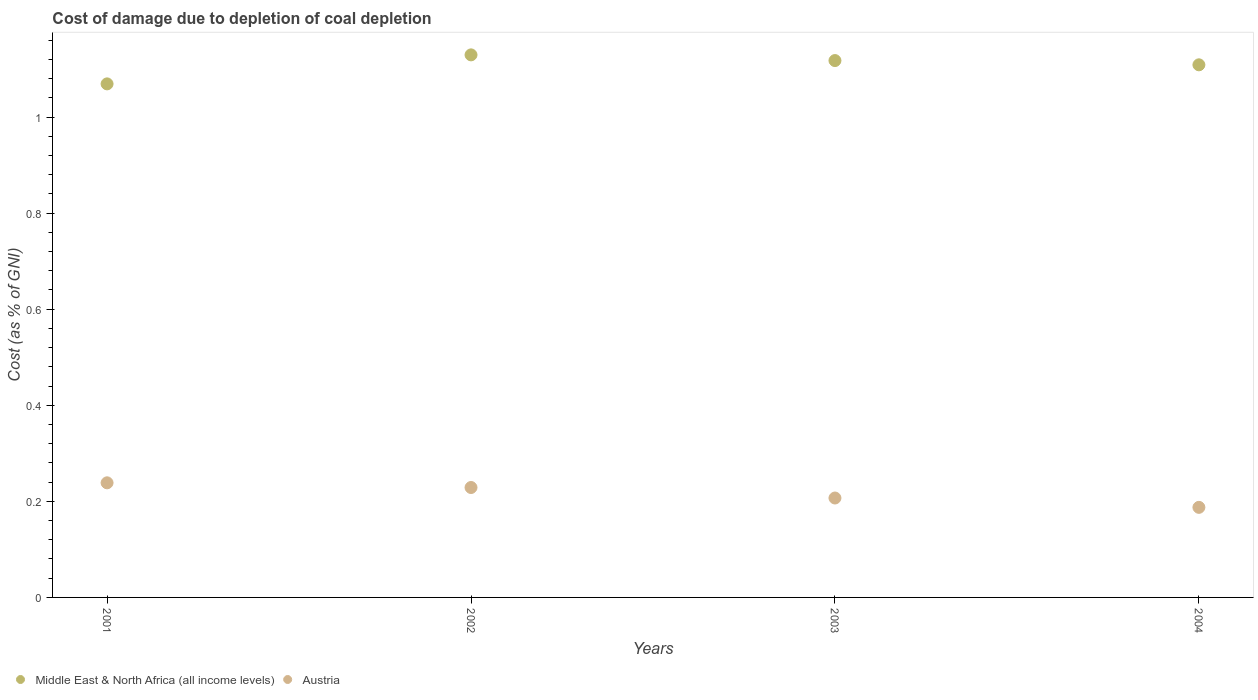What is the cost of damage caused due to coal depletion in Austria in 2003?
Provide a short and direct response. 0.21. Across all years, what is the maximum cost of damage caused due to coal depletion in Austria?
Give a very brief answer. 0.24. Across all years, what is the minimum cost of damage caused due to coal depletion in Austria?
Your answer should be very brief. 0.19. What is the total cost of damage caused due to coal depletion in Middle East & North Africa (all income levels) in the graph?
Make the answer very short. 4.42. What is the difference between the cost of damage caused due to coal depletion in Middle East & North Africa (all income levels) in 2001 and that in 2002?
Provide a succinct answer. -0.06. What is the difference between the cost of damage caused due to coal depletion in Middle East & North Africa (all income levels) in 2002 and the cost of damage caused due to coal depletion in Austria in 2003?
Keep it short and to the point. 0.92. What is the average cost of damage caused due to coal depletion in Austria per year?
Provide a short and direct response. 0.22. In the year 2002, what is the difference between the cost of damage caused due to coal depletion in Austria and cost of damage caused due to coal depletion in Middle East & North Africa (all income levels)?
Provide a short and direct response. -0.9. In how many years, is the cost of damage caused due to coal depletion in Austria greater than 0.68 %?
Offer a terse response. 0. What is the ratio of the cost of damage caused due to coal depletion in Austria in 2001 to that in 2004?
Your response must be concise. 1.27. Is the cost of damage caused due to coal depletion in Austria in 2002 less than that in 2004?
Ensure brevity in your answer.  No. Is the difference between the cost of damage caused due to coal depletion in Austria in 2002 and 2003 greater than the difference between the cost of damage caused due to coal depletion in Middle East & North Africa (all income levels) in 2002 and 2003?
Provide a short and direct response. Yes. What is the difference between the highest and the second highest cost of damage caused due to coal depletion in Austria?
Offer a terse response. 0.01. What is the difference between the highest and the lowest cost of damage caused due to coal depletion in Austria?
Keep it short and to the point. 0.05. Does the cost of damage caused due to coal depletion in Middle East & North Africa (all income levels) monotonically increase over the years?
Make the answer very short. No. How many dotlines are there?
Keep it short and to the point. 2. Does the graph contain any zero values?
Ensure brevity in your answer.  No. How many legend labels are there?
Offer a very short reply. 2. How are the legend labels stacked?
Ensure brevity in your answer.  Horizontal. What is the title of the graph?
Give a very brief answer. Cost of damage due to depletion of coal depletion. What is the label or title of the Y-axis?
Your answer should be very brief. Cost (as % of GNI). What is the Cost (as % of GNI) in Middle East & North Africa (all income levels) in 2001?
Keep it short and to the point. 1.07. What is the Cost (as % of GNI) in Austria in 2001?
Your answer should be compact. 0.24. What is the Cost (as % of GNI) of Middle East & North Africa (all income levels) in 2002?
Give a very brief answer. 1.13. What is the Cost (as % of GNI) of Austria in 2002?
Your answer should be compact. 0.23. What is the Cost (as % of GNI) of Middle East & North Africa (all income levels) in 2003?
Your answer should be very brief. 1.12. What is the Cost (as % of GNI) of Austria in 2003?
Your answer should be very brief. 0.21. What is the Cost (as % of GNI) of Middle East & North Africa (all income levels) in 2004?
Offer a very short reply. 1.11. What is the Cost (as % of GNI) in Austria in 2004?
Your answer should be compact. 0.19. Across all years, what is the maximum Cost (as % of GNI) of Middle East & North Africa (all income levels)?
Your response must be concise. 1.13. Across all years, what is the maximum Cost (as % of GNI) in Austria?
Give a very brief answer. 0.24. Across all years, what is the minimum Cost (as % of GNI) of Middle East & North Africa (all income levels)?
Your answer should be compact. 1.07. Across all years, what is the minimum Cost (as % of GNI) in Austria?
Provide a succinct answer. 0.19. What is the total Cost (as % of GNI) in Middle East & North Africa (all income levels) in the graph?
Your answer should be very brief. 4.42. What is the total Cost (as % of GNI) of Austria in the graph?
Offer a terse response. 0.86. What is the difference between the Cost (as % of GNI) of Middle East & North Africa (all income levels) in 2001 and that in 2002?
Keep it short and to the point. -0.06. What is the difference between the Cost (as % of GNI) in Austria in 2001 and that in 2002?
Provide a succinct answer. 0.01. What is the difference between the Cost (as % of GNI) of Middle East & North Africa (all income levels) in 2001 and that in 2003?
Keep it short and to the point. -0.05. What is the difference between the Cost (as % of GNI) of Austria in 2001 and that in 2003?
Make the answer very short. 0.03. What is the difference between the Cost (as % of GNI) in Middle East & North Africa (all income levels) in 2001 and that in 2004?
Keep it short and to the point. -0.04. What is the difference between the Cost (as % of GNI) of Austria in 2001 and that in 2004?
Ensure brevity in your answer.  0.05. What is the difference between the Cost (as % of GNI) in Middle East & North Africa (all income levels) in 2002 and that in 2003?
Your response must be concise. 0.01. What is the difference between the Cost (as % of GNI) of Austria in 2002 and that in 2003?
Provide a succinct answer. 0.02. What is the difference between the Cost (as % of GNI) of Middle East & North Africa (all income levels) in 2002 and that in 2004?
Provide a short and direct response. 0.02. What is the difference between the Cost (as % of GNI) of Austria in 2002 and that in 2004?
Ensure brevity in your answer.  0.04. What is the difference between the Cost (as % of GNI) of Middle East & North Africa (all income levels) in 2003 and that in 2004?
Ensure brevity in your answer.  0.01. What is the difference between the Cost (as % of GNI) in Austria in 2003 and that in 2004?
Ensure brevity in your answer.  0.02. What is the difference between the Cost (as % of GNI) of Middle East & North Africa (all income levels) in 2001 and the Cost (as % of GNI) of Austria in 2002?
Give a very brief answer. 0.84. What is the difference between the Cost (as % of GNI) in Middle East & North Africa (all income levels) in 2001 and the Cost (as % of GNI) in Austria in 2003?
Offer a very short reply. 0.86. What is the difference between the Cost (as % of GNI) in Middle East & North Africa (all income levels) in 2001 and the Cost (as % of GNI) in Austria in 2004?
Keep it short and to the point. 0.88. What is the difference between the Cost (as % of GNI) of Middle East & North Africa (all income levels) in 2002 and the Cost (as % of GNI) of Austria in 2003?
Your answer should be very brief. 0.92. What is the difference between the Cost (as % of GNI) in Middle East & North Africa (all income levels) in 2002 and the Cost (as % of GNI) in Austria in 2004?
Ensure brevity in your answer.  0.94. What is the difference between the Cost (as % of GNI) in Middle East & North Africa (all income levels) in 2003 and the Cost (as % of GNI) in Austria in 2004?
Provide a succinct answer. 0.93. What is the average Cost (as % of GNI) of Middle East & North Africa (all income levels) per year?
Make the answer very short. 1.11. What is the average Cost (as % of GNI) of Austria per year?
Your answer should be compact. 0.22. In the year 2001, what is the difference between the Cost (as % of GNI) in Middle East & North Africa (all income levels) and Cost (as % of GNI) in Austria?
Ensure brevity in your answer.  0.83. In the year 2002, what is the difference between the Cost (as % of GNI) in Middle East & North Africa (all income levels) and Cost (as % of GNI) in Austria?
Ensure brevity in your answer.  0.9. In the year 2003, what is the difference between the Cost (as % of GNI) of Middle East & North Africa (all income levels) and Cost (as % of GNI) of Austria?
Your response must be concise. 0.91. In the year 2004, what is the difference between the Cost (as % of GNI) in Middle East & North Africa (all income levels) and Cost (as % of GNI) in Austria?
Provide a succinct answer. 0.92. What is the ratio of the Cost (as % of GNI) in Middle East & North Africa (all income levels) in 2001 to that in 2002?
Make the answer very short. 0.95. What is the ratio of the Cost (as % of GNI) of Austria in 2001 to that in 2002?
Your answer should be very brief. 1.04. What is the ratio of the Cost (as % of GNI) in Middle East & North Africa (all income levels) in 2001 to that in 2003?
Give a very brief answer. 0.96. What is the ratio of the Cost (as % of GNI) in Austria in 2001 to that in 2003?
Keep it short and to the point. 1.15. What is the ratio of the Cost (as % of GNI) of Middle East & North Africa (all income levels) in 2001 to that in 2004?
Provide a short and direct response. 0.96. What is the ratio of the Cost (as % of GNI) of Austria in 2001 to that in 2004?
Ensure brevity in your answer.  1.27. What is the ratio of the Cost (as % of GNI) in Middle East & North Africa (all income levels) in 2002 to that in 2003?
Your response must be concise. 1.01. What is the ratio of the Cost (as % of GNI) in Austria in 2002 to that in 2003?
Offer a terse response. 1.11. What is the ratio of the Cost (as % of GNI) of Middle East & North Africa (all income levels) in 2002 to that in 2004?
Provide a short and direct response. 1.02. What is the ratio of the Cost (as % of GNI) of Austria in 2002 to that in 2004?
Your answer should be very brief. 1.22. What is the ratio of the Cost (as % of GNI) in Austria in 2003 to that in 2004?
Provide a short and direct response. 1.1. What is the difference between the highest and the second highest Cost (as % of GNI) in Middle East & North Africa (all income levels)?
Offer a terse response. 0.01. What is the difference between the highest and the second highest Cost (as % of GNI) in Austria?
Give a very brief answer. 0.01. What is the difference between the highest and the lowest Cost (as % of GNI) of Middle East & North Africa (all income levels)?
Provide a succinct answer. 0.06. What is the difference between the highest and the lowest Cost (as % of GNI) of Austria?
Your answer should be compact. 0.05. 